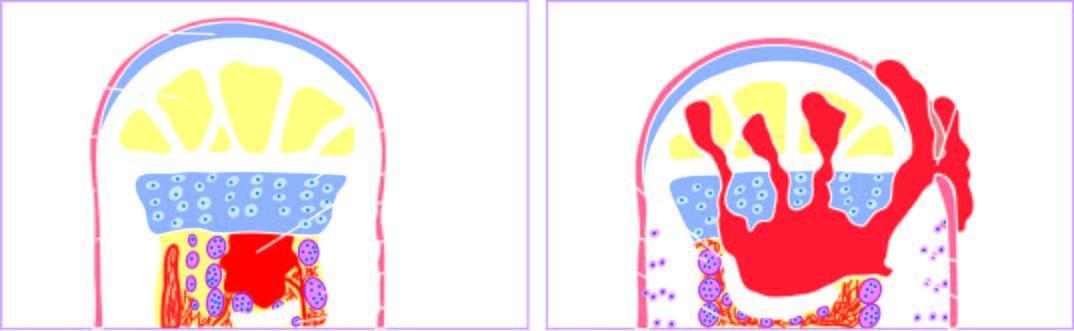what begins as a focus of microabscess in a vascular loop in the marrow which expands to stimulate?
Answer the question using a single word or phrase. Process 